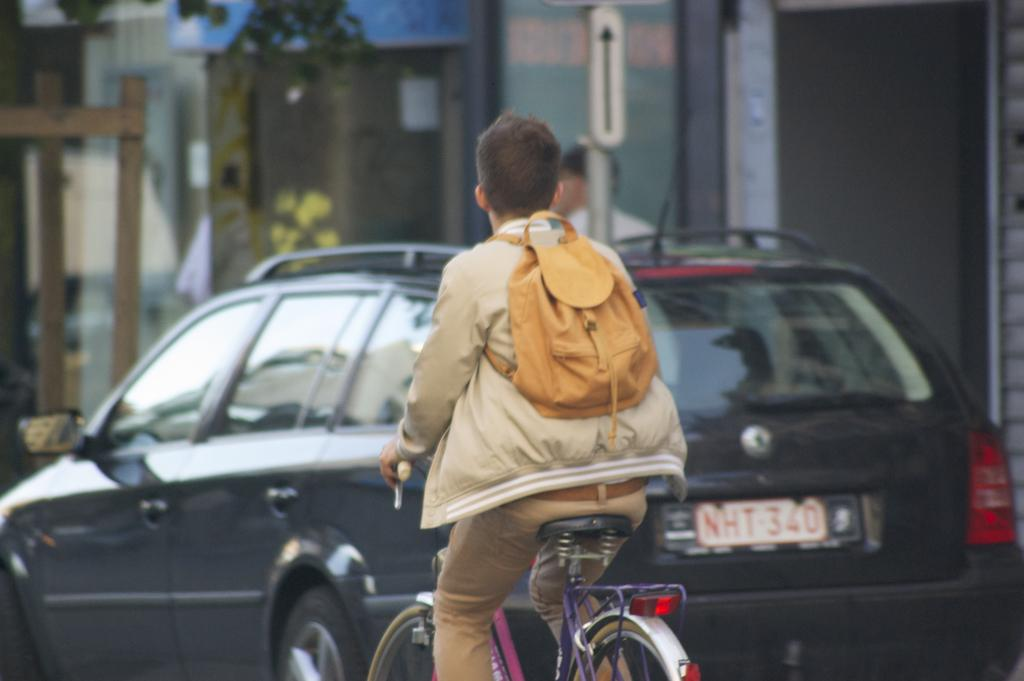Who is the main subject in the image? There is a man in the image. What is the man doing in the image? The man is riding a bicycle. What can be seen behind the man? There is a black car behind the man. What is visible in the background of the image? There is a building in the background of the image. What type of rhythm is the man playing on the bicycle in the image? There is no indication of the man playing any rhythm on the bicycle in the image. 